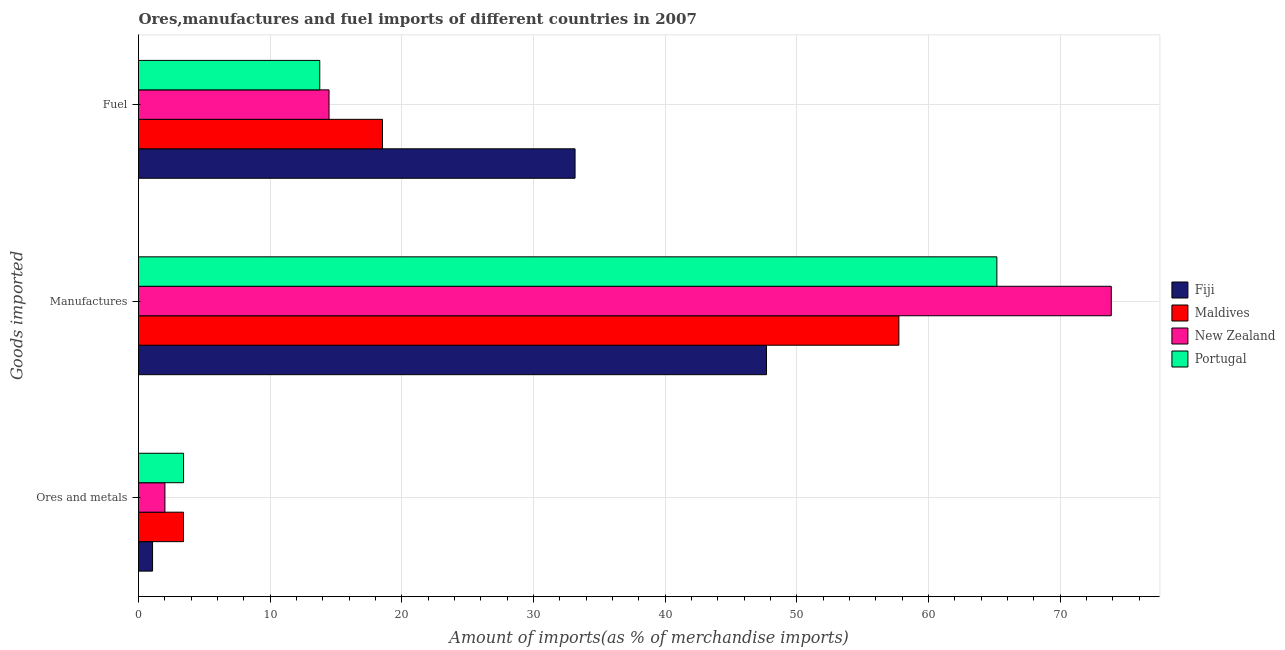How many groups of bars are there?
Make the answer very short. 3. Are the number of bars per tick equal to the number of legend labels?
Offer a terse response. Yes. Are the number of bars on each tick of the Y-axis equal?
Keep it short and to the point. Yes. How many bars are there on the 3rd tick from the bottom?
Provide a short and direct response. 4. What is the label of the 1st group of bars from the top?
Your answer should be compact. Fuel. What is the percentage of ores and metals imports in Portugal?
Offer a terse response. 3.42. Across all countries, what is the maximum percentage of fuel imports?
Make the answer very short. 33.16. Across all countries, what is the minimum percentage of manufactures imports?
Offer a terse response. 47.7. In which country was the percentage of fuel imports maximum?
Keep it short and to the point. Fiji. What is the total percentage of fuel imports in the graph?
Your response must be concise. 79.93. What is the difference between the percentage of manufactures imports in Maldives and that in New Zealand?
Ensure brevity in your answer.  -16.13. What is the difference between the percentage of manufactures imports in New Zealand and the percentage of fuel imports in Fiji?
Your answer should be very brief. 40.73. What is the average percentage of ores and metals imports per country?
Make the answer very short. 2.48. What is the difference between the percentage of ores and metals imports and percentage of fuel imports in Fiji?
Offer a very short reply. -32.09. What is the ratio of the percentage of manufactures imports in New Zealand to that in Portugal?
Provide a short and direct response. 1.13. What is the difference between the highest and the second highest percentage of manufactures imports?
Keep it short and to the point. 8.69. What is the difference between the highest and the lowest percentage of manufactures imports?
Ensure brevity in your answer.  26.19. Is the sum of the percentage of fuel imports in Fiji and Portugal greater than the maximum percentage of ores and metals imports across all countries?
Offer a terse response. Yes. What does the 2nd bar from the top in Ores and metals represents?
Your answer should be very brief. New Zealand. What does the 1st bar from the bottom in Manufactures represents?
Provide a succinct answer. Fiji. How many countries are there in the graph?
Your response must be concise. 4. Does the graph contain any zero values?
Provide a short and direct response. No. Does the graph contain grids?
Your response must be concise. Yes. How are the legend labels stacked?
Keep it short and to the point. Vertical. What is the title of the graph?
Make the answer very short. Ores,manufactures and fuel imports of different countries in 2007. Does "Belize" appear as one of the legend labels in the graph?
Keep it short and to the point. No. What is the label or title of the X-axis?
Keep it short and to the point. Amount of imports(as % of merchandise imports). What is the label or title of the Y-axis?
Your response must be concise. Goods imported. What is the Amount of imports(as % of merchandise imports) of Fiji in Ores and metals?
Your answer should be compact. 1.07. What is the Amount of imports(as % of merchandise imports) in Maldives in Ores and metals?
Offer a very short reply. 3.42. What is the Amount of imports(as % of merchandise imports) of New Zealand in Ores and metals?
Give a very brief answer. 2.01. What is the Amount of imports(as % of merchandise imports) in Portugal in Ores and metals?
Keep it short and to the point. 3.42. What is the Amount of imports(as % of merchandise imports) of Fiji in Manufactures?
Make the answer very short. 47.7. What is the Amount of imports(as % of merchandise imports) in Maldives in Manufactures?
Give a very brief answer. 57.75. What is the Amount of imports(as % of merchandise imports) in New Zealand in Manufactures?
Provide a short and direct response. 73.89. What is the Amount of imports(as % of merchandise imports) in Portugal in Manufactures?
Provide a succinct answer. 65.2. What is the Amount of imports(as % of merchandise imports) of Fiji in Fuel?
Give a very brief answer. 33.16. What is the Amount of imports(as % of merchandise imports) in Maldives in Fuel?
Provide a short and direct response. 18.53. What is the Amount of imports(as % of merchandise imports) of New Zealand in Fuel?
Provide a short and direct response. 14.47. What is the Amount of imports(as % of merchandise imports) of Portugal in Fuel?
Provide a succinct answer. 13.77. Across all Goods imported, what is the maximum Amount of imports(as % of merchandise imports) in Fiji?
Offer a terse response. 47.7. Across all Goods imported, what is the maximum Amount of imports(as % of merchandise imports) in Maldives?
Ensure brevity in your answer.  57.75. Across all Goods imported, what is the maximum Amount of imports(as % of merchandise imports) of New Zealand?
Provide a succinct answer. 73.89. Across all Goods imported, what is the maximum Amount of imports(as % of merchandise imports) in Portugal?
Make the answer very short. 65.2. Across all Goods imported, what is the minimum Amount of imports(as % of merchandise imports) in Fiji?
Make the answer very short. 1.07. Across all Goods imported, what is the minimum Amount of imports(as % of merchandise imports) in Maldives?
Provide a succinct answer. 3.42. Across all Goods imported, what is the minimum Amount of imports(as % of merchandise imports) in New Zealand?
Offer a very short reply. 2.01. Across all Goods imported, what is the minimum Amount of imports(as % of merchandise imports) of Portugal?
Ensure brevity in your answer.  3.42. What is the total Amount of imports(as % of merchandise imports) of Fiji in the graph?
Ensure brevity in your answer.  81.93. What is the total Amount of imports(as % of merchandise imports) in Maldives in the graph?
Offer a very short reply. 79.7. What is the total Amount of imports(as % of merchandise imports) in New Zealand in the graph?
Provide a succinct answer. 90.36. What is the total Amount of imports(as % of merchandise imports) in Portugal in the graph?
Offer a terse response. 82.39. What is the difference between the Amount of imports(as % of merchandise imports) of Fiji in Ores and metals and that in Manufactures?
Offer a terse response. -46.63. What is the difference between the Amount of imports(as % of merchandise imports) of Maldives in Ores and metals and that in Manufactures?
Provide a succinct answer. -54.34. What is the difference between the Amount of imports(as % of merchandise imports) in New Zealand in Ores and metals and that in Manufactures?
Give a very brief answer. -71.88. What is the difference between the Amount of imports(as % of merchandise imports) of Portugal in Ores and metals and that in Manufactures?
Offer a very short reply. -61.78. What is the difference between the Amount of imports(as % of merchandise imports) in Fiji in Ores and metals and that in Fuel?
Give a very brief answer. -32.09. What is the difference between the Amount of imports(as % of merchandise imports) of Maldives in Ores and metals and that in Fuel?
Make the answer very short. -15.12. What is the difference between the Amount of imports(as % of merchandise imports) of New Zealand in Ores and metals and that in Fuel?
Give a very brief answer. -12.47. What is the difference between the Amount of imports(as % of merchandise imports) in Portugal in Ores and metals and that in Fuel?
Make the answer very short. -10.35. What is the difference between the Amount of imports(as % of merchandise imports) in Fiji in Manufactures and that in Fuel?
Ensure brevity in your answer.  14.54. What is the difference between the Amount of imports(as % of merchandise imports) in Maldives in Manufactures and that in Fuel?
Give a very brief answer. 39.22. What is the difference between the Amount of imports(as % of merchandise imports) of New Zealand in Manufactures and that in Fuel?
Give a very brief answer. 59.42. What is the difference between the Amount of imports(as % of merchandise imports) in Portugal in Manufactures and that in Fuel?
Provide a short and direct response. 51.43. What is the difference between the Amount of imports(as % of merchandise imports) of Fiji in Ores and metals and the Amount of imports(as % of merchandise imports) of Maldives in Manufactures?
Offer a terse response. -56.69. What is the difference between the Amount of imports(as % of merchandise imports) of Fiji in Ores and metals and the Amount of imports(as % of merchandise imports) of New Zealand in Manufactures?
Provide a succinct answer. -72.82. What is the difference between the Amount of imports(as % of merchandise imports) of Fiji in Ores and metals and the Amount of imports(as % of merchandise imports) of Portugal in Manufactures?
Ensure brevity in your answer.  -64.13. What is the difference between the Amount of imports(as % of merchandise imports) of Maldives in Ores and metals and the Amount of imports(as % of merchandise imports) of New Zealand in Manufactures?
Offer a terse response. -70.47. What is the difference between the Amount of imports(as % of merchandise imports) of Maldives in Ores and metals and the Amount of imports(as % of merchandise imports) of Portugal in Manufactures?
Your answer should be compact. -61.78. What is the difference between the Amount of imports(as % of merchandise imports) of New Zealand in Ores and metals and the Amount of imports(as % of merchandise imports) of Portugal in Manufactures?
Your response must be concise. -63.19. What is the difference between the Amount of imports(as % of merchandise imports) of Fiji in Ores and metals and the Amount of imports(as % of merchandise imports) of Maldives in Fuel?
Offer a terse response. -17.46. What is the difference between the Amount of imports(as % of merchandise imports) in Fiji in Ores and metals and the Amount of imports(as % of merchandise imports) in New Zealand in Fuel?
Offer a very short reply. -13.4. What is the difference between the Amount of imports(as % of merchandise imports) of Maldives in Ores and metals and the Amount of imports(as % of merchandise imports) of New Zealand in Fuel?
Your answer should be very brief. -11.05. What is the difference between the Amount of imports(as % of merchandise imports) in Maldives in Ores and metals and the Amount of imports(as % of merchandise imports) in Portugal in Fuel?
Keep it short and to the point. -10.35. What is the difference between the Amount of imports(as % of merchandise imports) in New Zealand in Ores and metals and the Amount of imports(as % of merchandise imports) in Portugal in Fuel?
Provide a short and direct response. -11.76. What is the difference between the Amount of imports(as % of merchandise imports) in Fiji in Manufactures and the Amount of imports(as % of merchandise imports) in Maldives in Fuel?
Offer a terse response. 29.17. What is the difference between the Amount of imports(as % of merchandise imports) in Fiji in Manufactures and the Amount of imports(as % of merchandise imports) in New Zealand in Fuel?
Your answer should be very brief. 33.23. What is the difference between the Amount of imports(as % of merchandise imports) in Fiji in Manufactures and the Amount of imports(as % of merchandise imports) in Portugal in Fuel?
Your answer should be very brief. 33.93. What is the difference between the Amount of imports(as % of merchandise imports) of Maldives in Manufactures and the Amount of imports(as % of merchandise imports) of New Zealand in Fuel?
Provide a short and direct response. 43.28. What is the difference between the Amount of imports(as % of merchandise imports) in Maldives in Manufactures and the Amount of imports(as % of merchandise imports) in Portugal in Fuel?
Give a very brief answer. 43.99. What is the difference between the Amount of imports(as % of merchandise imports) in New Zealand in Manufactures and the Amount of imports(as % of merchandise imports) in Portugal in Fuel?
Give a very brief answer. 60.12. What is the average Amount of imports(as % of merchandise imports) of Fiji per Goods imported?
Your answer should be very brief. 27.31. What is the average Amount of imports(as % of merchandise imports) in Maldives per Goods imported?
Offer a terse response. 26.57. What is the average Amount of imports(as % of merchandise imports) in New Zealand per Goods imported?
Keep it short and to the point. 30.12. What is the average Amount of imports(as % of merchandise imports) of Portugal per Goods imported?
Provide a succinct answer. 27.46. What is the difference between the Amount of imports(as % of merchandise imports) in Fiji and Amount of imports(as % of merchandise imports) in Maldives in Ores and metals?
Give a very brief answer. -2.35. What is the difference between the Amount of imports(as % of merchandise imports) in Fiji and Amount of imports(as % of merchandise imports) in New Zealand in Ores and metals?
Your answer should be compact. -0.94. What is the difference between the Amount of imports(as % of merchandise imports) of Fiji and Amount of imports(as % of merchandise imports) of Portugal in Ores and metals?
Your answer should be compact. -2.35. What is the difference between the Amount of imports(as % of merchandise imports) of Maldives and Amount of imports(as % of merchandise imports) of New Zealand in Ores and metals?
Make the answer very short. 1.41. What is the difference between the Amount of imports(as % of merchandise imports) of Maldives and Amount of imports(as % of merchandise imports) of Portugal in Ores and metals?
Make the answer very short. -0.01. What is the difference between the Amount of imports(as % of merchandise imports) in New Zealand and Amount of imports(as % of merchandise imports) in Portugal in Ores and metals?
Your answer should be compact. -1.42. What is the difference between the Amount of imports(as % of merchandise imports) of Fiji and Amount of imports(as % of merchandise imports) of Maldives in Manufactures?
Your response must be concise. -10.06. What is the difference between the Amount of imports(as % of merchandise imports) in Fiji and Amount of imports(as % of merchandise imports) in New Zealand in Manufactures?
Provide a short and direct response. -26.19. What is the difference between the Amount of imports(as % of merchandise imports) in Fiji and Amount of imports(as % of merchandise imports) in Portugal in Manufactures?
Ensure brevity in your answer.  -17.5. What is the difference between the Amount of imports(as % of merchandise imports) of Maldives and Amount of imports(as % of merchandise imports) of New Zealand in Manufactures?
Your answer should be very brief. -16.13. What is the difference between the Amount of imports(as % of merchandise imports) of Maldives and Amount of imports(as % of merchandise imports) of Portugal in Manufactures?
Your answer should be very brief. -7.44. What is the difference between the Amount of imports(as % of merchandise imports) in New Zealand and Amount of imports(as % of merchandise imports) in Portugal in Manufactures?
Make the answer very short. 8.69. What is the difference between the Amount of imports(as % of merchandise imports) in Fiji and Amount of imports(as % of merchandise imports) in Maldives in Fuel?
Offer a terse response. 14.63. What is the difference between the Amount of imports(as % of merchandise imports) of Fiji and Amount of imports(as % of merchandise imports) of New Zealand in Fuel?
Your answer should be compact. 18.69. What is the difference between the Amount of imports(as % of merchandise imports) of Fiji and Amount of imports(as % of merchandise imports) of Portugal in Fuel?
Give a very brief answer. 19.39. What is the difference between the Amount of imports(as % of merchandise imports) in Maldives and Amount of imports(as % of merchandise imports) in New Zealand in Fuel?
Your answer should be compact. 4.06. What is the difference between the Amount of imports(as % of merchandise imports) of Maldives and Amount of imports(as % of merchandise imports) of Portugal in Fuel?
Provide a short and direct response. 4.76. What is the difference between the Amount of imports(as % of merchandise imports) in New Zealand and Amount of imports(as % of merchandise imports) in Portugal in Fuel?
Your answer should be very brief. 0.7. What is the ratio of the Amount of imports(as % of merchandise imports) in Fiji in Ores and metals to that in Manufactures?
Keep it short and to the point. 0.02. What is the ratio of the Amount of imports(as % of merchandise imports) of Maldives in Ores and metals to that in Manufactures?
Provide a succinct answer. 0.06. What is the ratio of the Amount of imports(as % of merchandise imports) of New Zealand in Ores and metals to that in Manufactures?
Your answer should be very brief. 0.03. What is the ratio of the Amount of imports(as % of merchandise imports) of Portugal in Ores and metals to that in Manufactures?
Make the answer very short. 0.05. What is the ratio of the Amount of imports(as % of merchandise imports) in Fiji in Ores and metals to that in Fuel?
Keep it short and to the point. 0.03. What is the ratio of the Amount of imports(as % of merchandise imports) in Maldives in Ores and metals to that in Fuel?
Make the answer very short. 0.18. What is the ratio of the Amount of imports(as % of merchandise imports) of New Zealand in Ores and metals to that in Fuel?
Ensure brevity in your answer.  0.14. What is the ratio of the Amount of imports(as % of merchandise imports) in Portugal in Ores and metals to that in Fuel?
Keep it short and to the point. 0.25. What is the ratio of the Amount of imports(as % of merchandise imports) of Fiji in Manufactures to that in Fuel?
Give a very brief answer. 1.44. What is the ratio of the Amount of imports(as % of merchandise imports) in Maldives in Manufactures to that in Fuel?
Ensure brevity in your answer.  3.12. What is the ratio of the Amount of imports(as % of merchandise imports) in New Zealand in Manufactures to that in Fuel?
Your response must be concise. 5.11. What is the ratio of the Amount of imports(as % of merchandise imports) in Portugal in Manufactures to that in Fuel?
Make the answer very short. 4.74. What is the difference between the highest and the second highest Amount of imports(as % of merchandise imports) in Fiji?
Make the answer very short. 14.54. What is the difference between the highest and the second highest Amount of imports(as % of merchandise imports) in Maldives?
Provide a succinct answer. 39.22. What is the difference between the highest and the second highest Amount of imports(as % of merchandise imports) of New Zealand?
Your answer should be compact. 59.42. What is the difference between the highest and the second highest Amount of imports(as % of merchandise imports) in Portugal?
Your answer should be compact. 51.43. What is the difference between the highest and the lowest Amount of imports(as % of merchandise imports) of Fiji?
Make the answer very short. 46.63. What is the difference between the highest and the lowest Amount of imports(as % of merchandise imports) in Maldives?
Your response must be concise. 54.34. What is the difference between the highest and the lowest Amount of imports(as % of merchandise imports) of New Zealand?
Ensure brevity in your answer.  71.88. What is the difference between the highest and the lowest Amount of imports(as % of merchandise imports) in Portugal?
Offer a terse response. 61.78. 